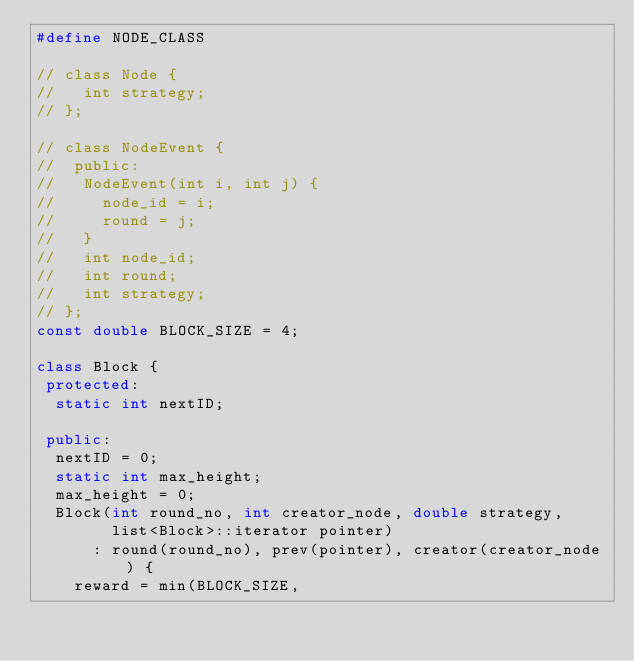<code> <loc_0><loc_0><loc_500><loc_500><_C++_>#define NODE_CLASS

// class Node {
//   int strategy;
// };

// class NodeEvent {
//  public:
//   NodeEvent(int i, int j) {
//     node_id = i;
//     round = j;
//   }
//   int node_id;
//   int round;
//   int strategy;
// };
const double BLOCK_SIZE = 4;

class Block {
 protected:
  static int nextID;

 public:
  nextID = 0;
  static int max_height;
  max_height = 0;
  Block(int round_no, int creator_node, double strategy,
        list<Block>::iterator pointer)
      : round(round_no), prev(pointer), creator(creator_node) {
    reward = min(BLOCK_SIZE,</code> 